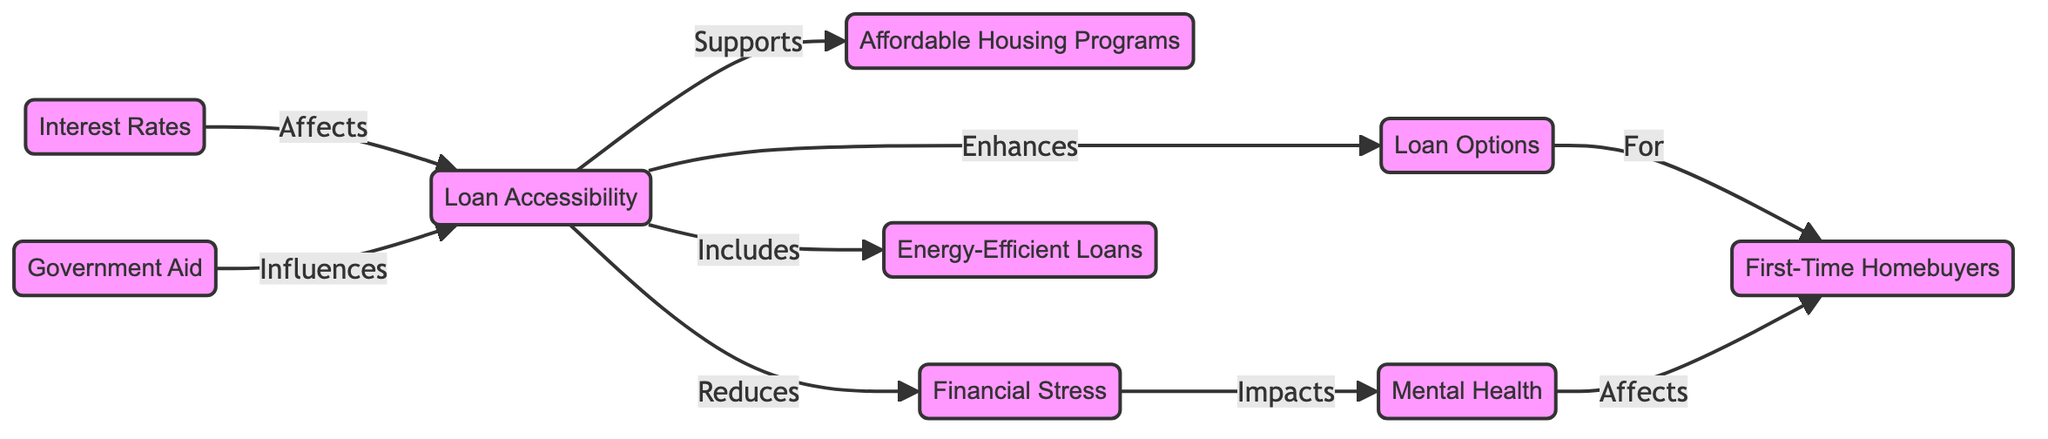What is the primary node in this diagram? The primary node in the diagram is "Loan Options" as it serves as the starting point for the flow to first-time homebuyers.
Answer: Loan Options How many main nodes are presented in the diagram? The diagram contains eight main nodes: Loan Options, First-Time Homebuyers, Loan Accessibility, Mental Health, Affordable Housing Programs, Interest Rates, Financial Stress, and Energy-Efficient Loans.
Answer: Eight What does the "Loan Accessibility" node enhance? The "Loan Accessibility" node enhances the "Loan Options" offered to first-time homebuyers.
Answer: Loan Options Which node impacts mental health according to the diagram? The "Financial Stress" node directly impacts "Mental Health," indicating a negative effect on individuals facing financial pressure.
Answer: Financial Stress What is the relationship between "Interest Rates" and "Loan Accessibility"? The relationship is that "Interest Rates" affect "Loan Accessibility," suggesting that changes in interest rates can influence the availability of loans.
Answer: Affects How does "Government Aid" influence "Loan Accessibility"? "Government Aid" influences "Loan Accessibility" by providing support that can make obtaining loans easier for first-time homebuyers.
Answer: Influences What effect does "Loan Accessibility" have on "Financial Stress"? "Loan Accessibility" reduces "Financial Stress," indicating that better access to loans can alleviate financial burdens on homebuyers.
Answer: Reduces Which node is supported by "Loan Accessibility"? The "Loan Accessibility" node supports "Affordable Housing Programs," linking accessibility to beneficial housing options for buyers.
Answer: Affordable Housing Programs How does mental health affect first-time homebuyers? According to the diagram, "Mental Health" affects "First-Time Homebuyers" by influencing their overall experience and decision-making processes related to purchasing a home.
Answer: Affects 